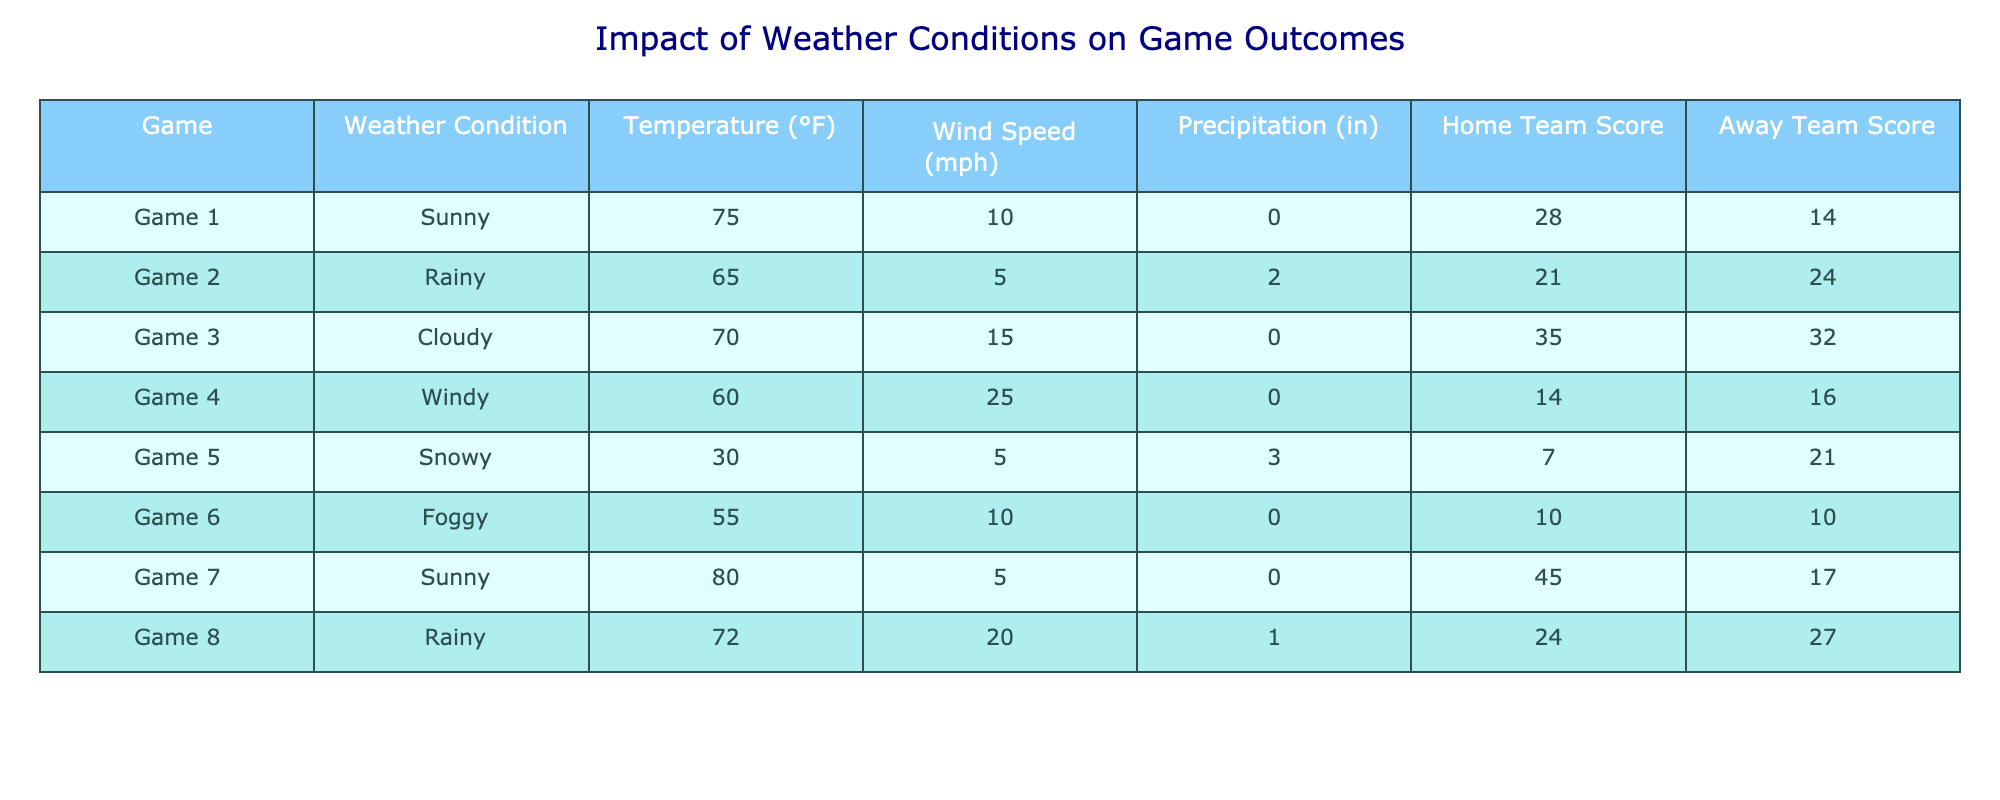What was the score difference in Game 2? In Game 2, the home team scored 21 points while the away team scored 24 points. To find the score difference, we subtract the home team score from the away team score: 24 - 21 = 3.
Answer: 3 What is the highest temperature recorded during the games? The temperatures for the games are as follows: 75, 65, 70, 60, 30, 55, 80, and 72 degrees Fahrenheit. The highest among these is 80 degrees Fahrenheit from Game 7.
Answer: 80°F Did the home team win in Game 5? In Game 5, the home team scored 7 points while the away team scored 21 points. Since the home team scored less than the away team, they did not win.
Answer: No What is the average wind speed across all games? The wind speeds from the games are: 10, 5, 15, 25, 5, 10, 5, and 20 mph. To find the average, we add these values: 10 + 5 + 15 + 25 + 5 + 10 + 5 + 20 = 95 mph. Then we divide by the number of games (8): 95 / 8 = 11.875 mph.
Answer: 11.875 mph How many games had a score where the home team lost by more than 10 points? Analyzing the score differences: Game 1 (14), Game 2 (3), Game 3 (3), Game 4 (2), Game 5 (14), Game 6 (0), Game 7 (28), Game 8 (3). Only Game 5 (14 points difference) and Game 7 (28 points difference) had losses by more than 10 points. Thus, there are 2 games.
Answer: 2 What is the total score of the away teams? The away team scores are: 14, 24, 32, 16, 21, 10, 17, and 27. Summing these scores gives: 14 + 24 + 32 + 16 + 21 + 10 + 17 + 27 =  171.
Answer: 171 Which weather condition recorded the lowest temperature? The temperatures corresponding to the weather conditions are: Sunny (75), Rainy (65), Cloudy (70), Windy (60), Snowy (30), Foggy (55). The lowest temperature is 30 degrees Fahrenheit from the Snowy condition.
Answer: Snowy How many games were played under rainy conditions? There are two instances in the table where the weather condition is Rainy: Game 2 and Game 8. Therefore, a total of 2 games were played under rainy conditions.
Answer: 2 What was the highest score achieved by a home team? The home team scores are: 28, 21, 35, 14, 7, 10, 45, and 24. The highest score among these is 45 points from Game 7.
Answer: 45 